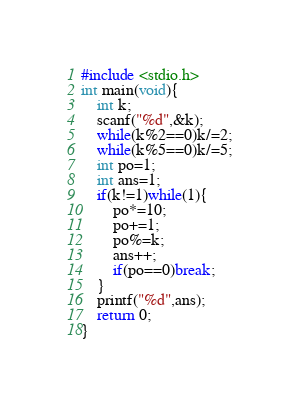Convert code to text. <code><loc_0><loc_0><loc_500><loc_500><_C_>#include <stdio.h>
int main(void){
    int k;
    scanf("%d",&k);
    while(k%2==0)k/=2;
    while(k%5==0)k/=5;
    int po=1;
    int ans=1;
    if(k!=1)while(1){
        po*=10;
        po+=1;
        po%=k;
        ans++;
        if(po==0)break;
    }
    printf("%d",ans);
    return 0;
}
</code> 